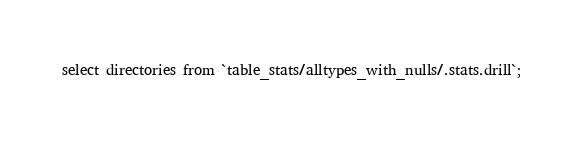<code> <loc_0><loc_0><loc_500><loc_500><_SQL_>select directories from `table_stats/alltypes_with_nulls/.stats.drill`;
</code> 